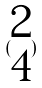<formula> <loc_0><loc_0><loc_500><loc_500>( \begin{matrix} 2 \\ 4 \end{matrix} )</formula> 